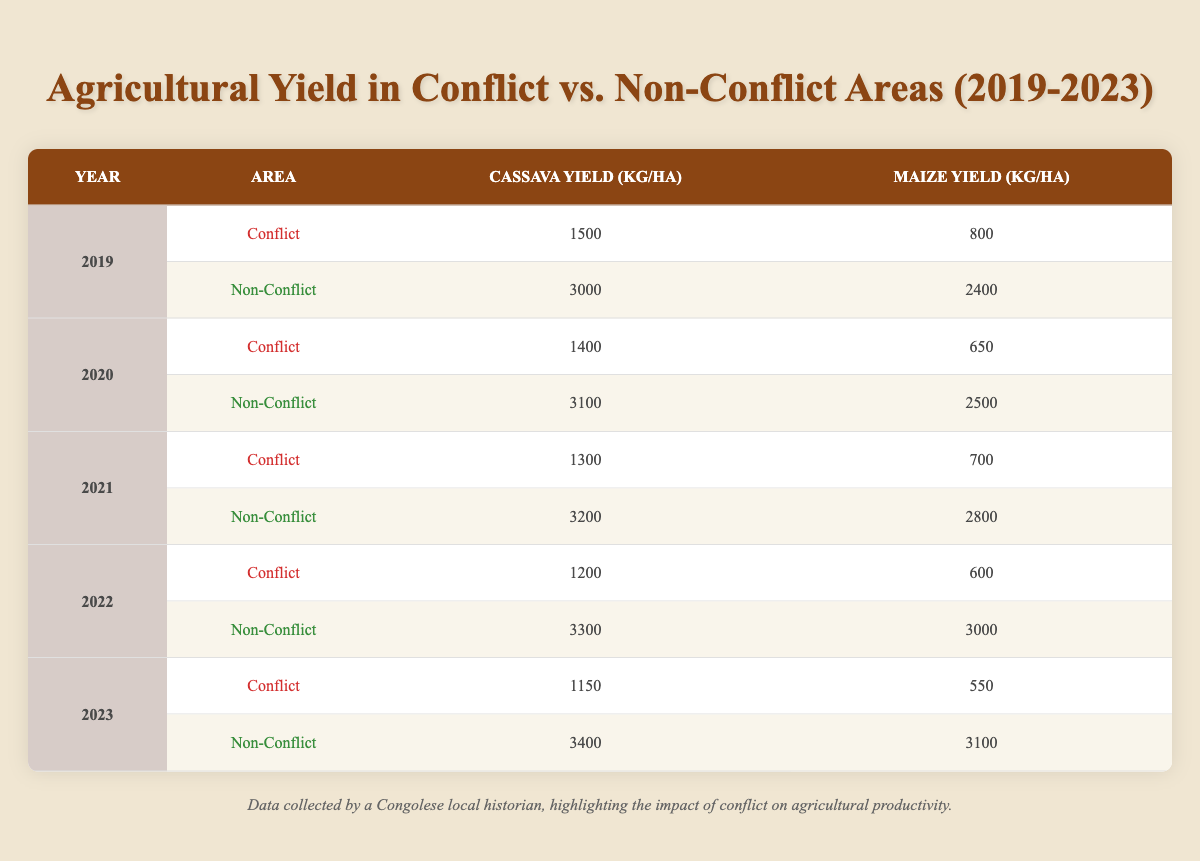What was the cassava yield in conflict areas in 2021? Referring to the table, the cassava yield in conflict areas for the year 2021 is listed as 1300 kg/ha.
Answer: 1300 kg/ha What year had the highest maize yield in non-conflict areas? By examining the table, the maize yield in non-conflict areas peaked in 2022 at 3000 kg/ha.
Answer: 2022 What is the difference in cassava yield between conflict and non-conflict areas in 2019? The cassava yield in conflict areas for 2019 is 1500 kg/ha, and in non-conflict areas, it is 3000 kg/ha. The difference is 3000 - 1500 = 1500 kg/ha.
Answer: 1500 kg/ha What is the average cassava yield in non-conflict areas over the five years? The cassava yields in non-conflict areas across the years are: 3000 (2019), 3100 (2020), 3200 (2021), 3300 (2022), and 3400 (2023). Adding these yields gives 3000 + 3100 + 3200 + 3300 + 3400 = 16000. Dividing by 5 results in an average of 16000 / 5 = 3200 kg/ha.
Answer: 3200 kg/ha Did any year have a maize yield below 600 kg/ha in conflict areas? The table indicates that the maize yields in conflict areas were 800 (2019), 650 (2020), 700 (2021), 600 (2022), and 550 (2023). Since 550 in 2023 is below 600, the answer is yes.
Answer: Yes Which crop had a higher yield consistently in non-conflict areas across all years? By analyzing the table, we can compare the yields for cassava and maize each year in non-conflict areas: cassava yields are 3000, 3100, 3200, 3300, and 3400 kg/ha, while maize yields are 2400, 2500, 2800, 3000, and 3100 kg/ha. Cassava is consistently higher than maize in each of the five years.
Answer: Cassava What was the total yield of cassava in conflict areas from 2019 to 2023? The table provides the cassava yields in conflict areas as follows: 1500 (2019), 1400 (2020), 1300 (2021), 1200 (2022), and 1150 (2023). By adding these yields, we get 1500 + 1400 + 1300 + 1200 + 1150 = 6550 kg/ha as the total yield.
Answer: 6550 kg/ha 